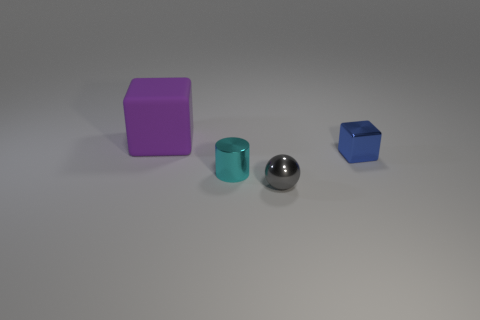Does the tiny thing that is right of the small gray object have the same shape as the thing that is behind the metal block?
Give a very brief answer. Yes. There is a tiny sphere that is the same material as the small cylinder; what color is it?
Give a very brief answer. Gray. Are there fewer metallic blocks that are on the right side of the blue object than tiny metal cylinders?
Provide a short and direct response. Yes. There is a block that is behind the cube in front of the cube behind the tiny cube; what size is it?
Keep it short and to the point. Large. Do the thing that is in front of the small cyan metal cylinder and the cyan object have the same material?
Give a very brief answer. Yes. Is there anything else that has the same shape as the large purple object?
Provide a short and direct response. Yes. What number of things are small green rubber blocks or gray balls?
Keep it short and to the point. 1. There is a purple matte object that is the same shape as the tiny blue thing; what is its size?
Your answer should be very brief. Large. Is there anything else that has the same size as the blue cube?
Offer a terse response. Yes. What number of cubes are big gray metal objects or tiny gray metal things?
Ensure brevity in your answer.  0. 